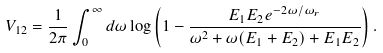<formula> <loc_0><loc_0><loc_500><loc_500>V _ { 1 2 } = \frac { 1 } { 2 \pi } \int _ { 0 } ^ { \infty } d \omega \log \left ( 1 - \frac { E _ { 1 } E _ { 2 } e ^ { - 2 \omega / \omega _ { r } } } { \omega ^ { 2 } + \omega ( E _ { 1 } + E _ { 2 } ) + E _ { 1 } E _ { 2 } } \right ) .</formula> 